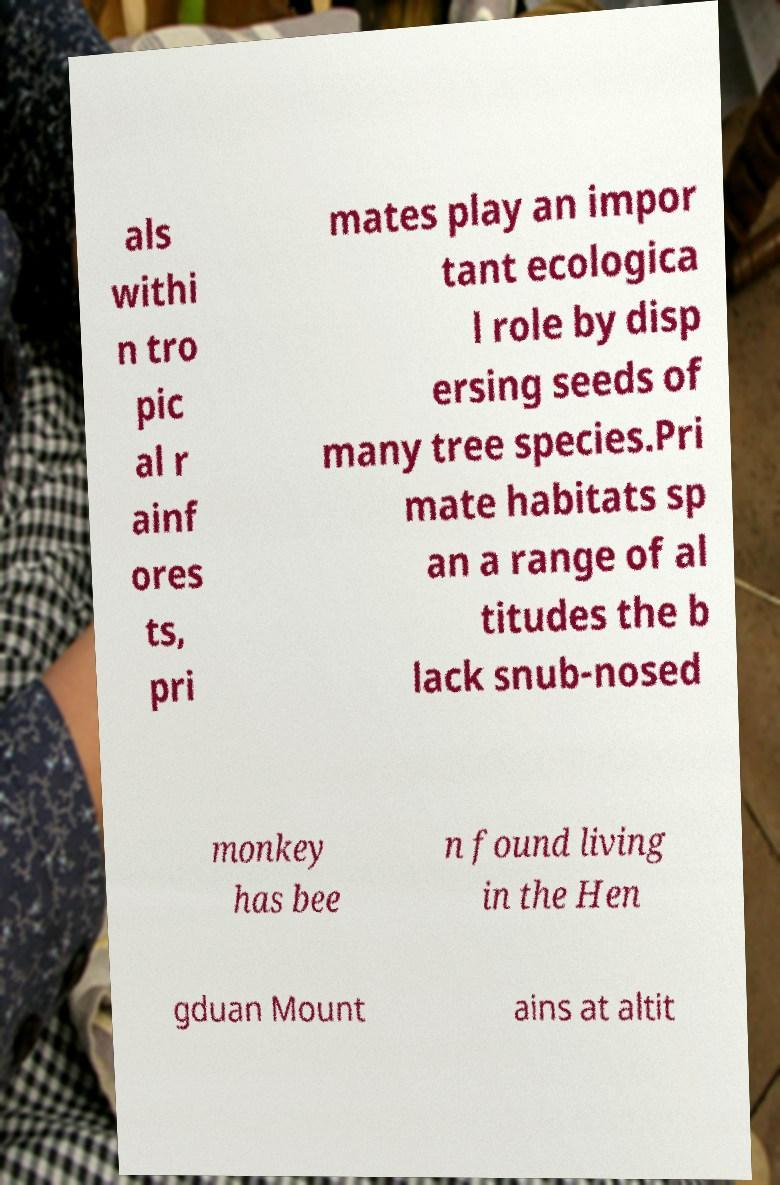I need the written content from this picture converted into text. Can you do that? als withi n tro pic al r ainf ores ts, pri mates play an impor tant ecologica l role by disp ersing seeds of many tree species.Pri mate habitats sp an a range of al titudes the b lack snub-nosed monkey has bee n found living in the Hen gduan Mount ains at altit 